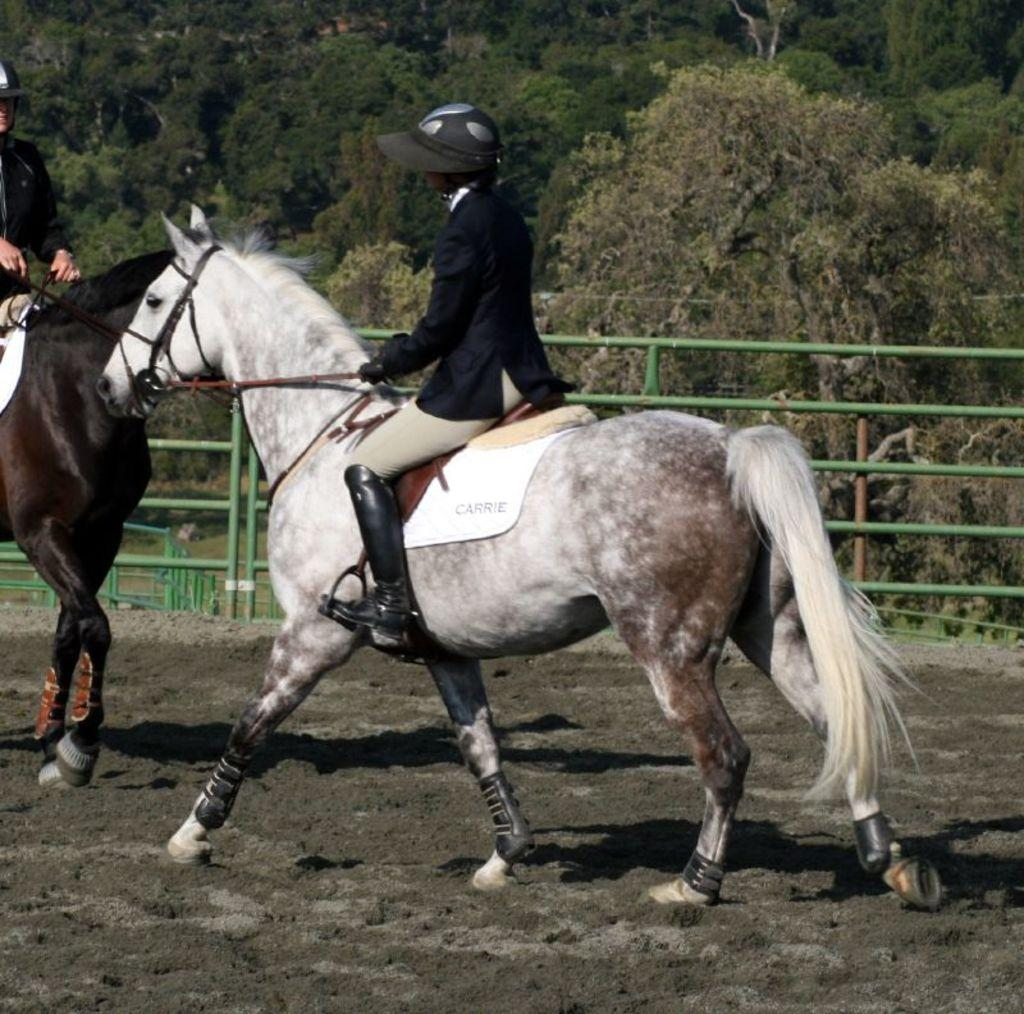How many people are in the image? There are two people in the image. What are the people doing in the image? The people are riding horses. What can be seen in the background of the image? There are green barricades and trees visible in the image. What is the terrain like in the image? There is mud in the image, suggesting a potentially wet or damp environment. What type of bedroom can be seen in the image? There is no bedroom present in the image; it features two people riding horses in an outdoor setting. 